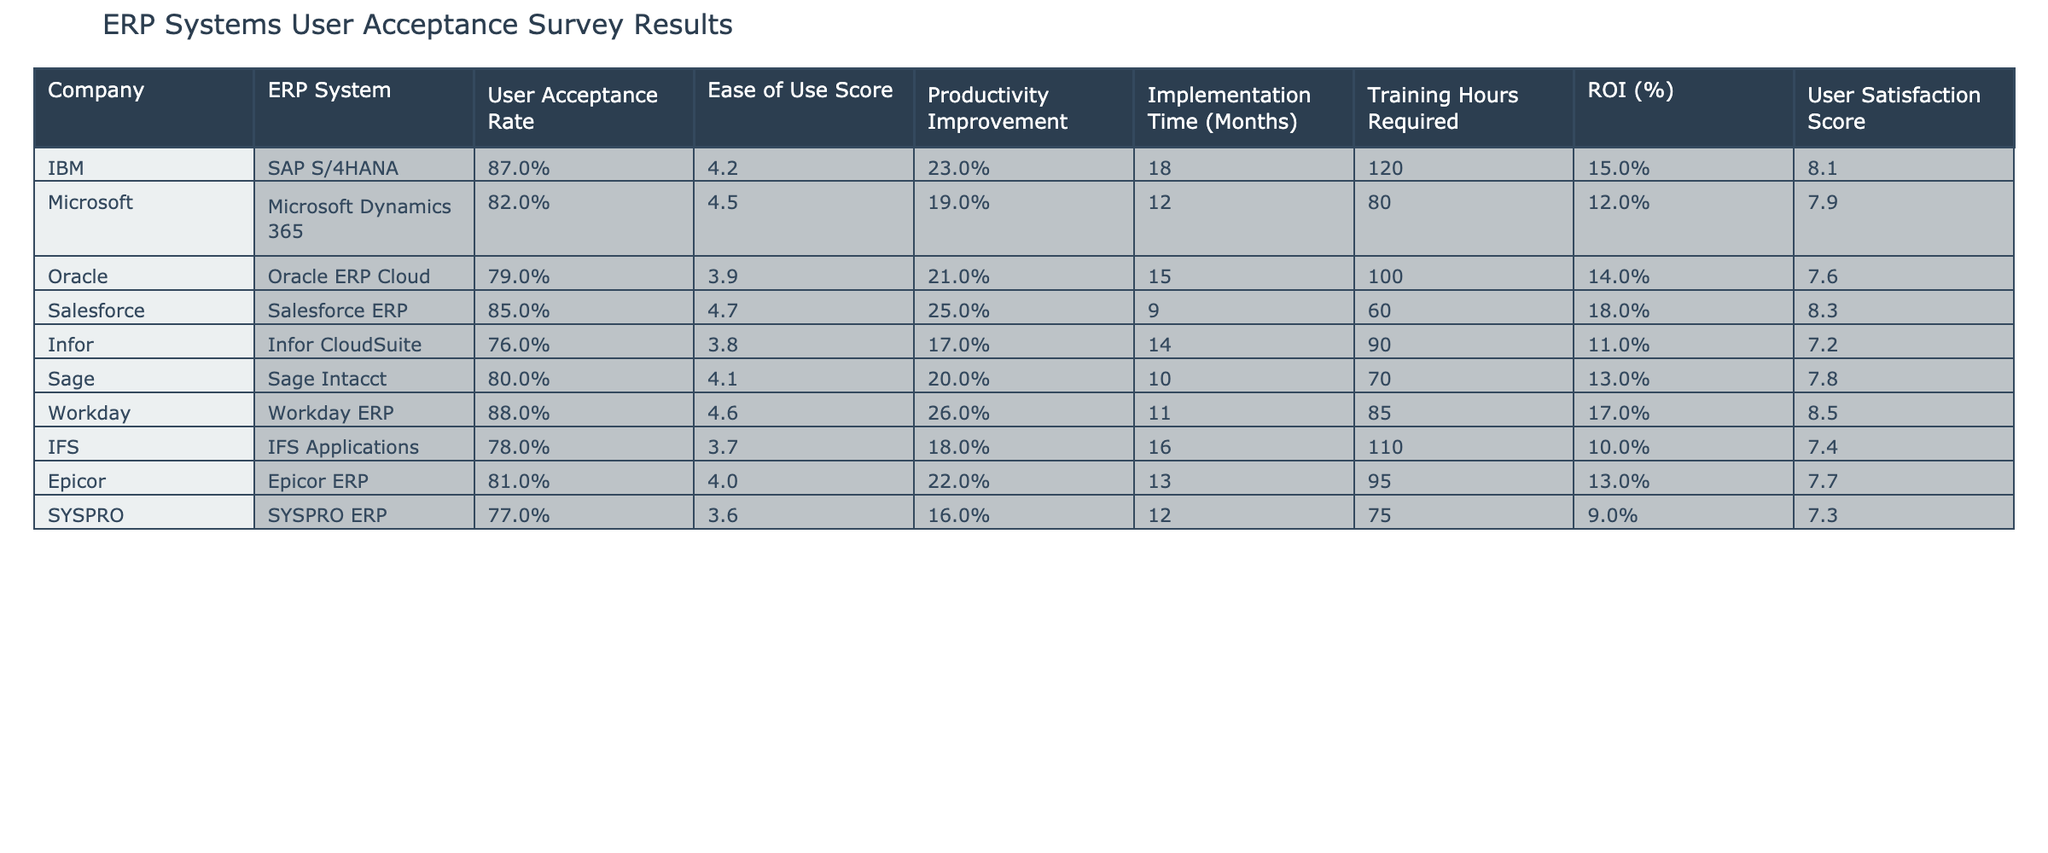What is the highest user acceptance rate among the ERP systems? The user acceptance rates for the systems are: IBM (87%), Microsoft (82%), Oracle (79%), Salesforce (85%), Infor (76%), Sage (80%), Workday (88%), IFS (78%), Epicor (81%), and SYSPRO (77%). The highest rate is 88% for Workday ERP.
Answer: 88% Which ERP system requires the least training hours? The training hours required for each system are: IBM (120), Microsoft (80), Oracle (100), Salesforce (60), Infor (90), Sage (70), Workday (85), IFS (110), Epicor (95), and SYSPRO (75). Salesforce requires the least at 60 hours.
Answer: 60 What is the implementation time for Salesforce ERP? According to the table, the implementation time for Salesforce ERP is 9 months.
Answer: 9 months Is the ROI for Oracle ERP Cloud higher than that of Sage Intacct? The ROI for Oracle ERP Cloud is 14%, while for Sage Intacct it is 13%. Since 14% is greater than 13%, the answer is yes.
Answer: Yes Which ERP system has the highest productivity improvement percentage? The productivity improvement percentages for the systems are: IBM (23%), Microsoft (19%), Oracle (21%), Salesforce (25%), Infor (17%), Sage (20%), Workday (26%), IFS (18%), Epicor (22%), and SYSPRO (16%). Workday has the highest at 26%.
Answer: 26% Calculate the average user satisfaction score across all ERP systems. The user satisfaction scores are: IBM (8.1), Microsoft (7.9), Oracle (7.6), Salesforce (8.3), Infor (7.2), Sage (7.8), Workday (8.5), IFS (7.4), Epicor (7.7), and SYSPRO (7.3). Summing these gives 79.8, and dividing by 10 (the number of systems) results in 7.98.
Answer: 7.98 Does any ERP system have a user satisfaction score of 9 or higher? The user satisfaction scores are all below 9, with the highest being 8.5 for Workday ERP. Therefore, there is no ERP system with a score of 9 or higher.
Answer: No Which company implemented their ERP system in more than a year? The implementation times are: IBM (18 months), Microsoft (12 months), Oracle (15 months), Salesforce (9 months), Infor (14 months), Sage (10 months), Workday (11 months), IFS (16 months), Epicor (13 months), and SYSPRO (12 months). IBM, Oracle, Infor, and IFS all implemented their systems in more than 12 months.
Answer: IBM, Oracle, Infor, IFS What is the relationship between user acceptance rate and ease of use score for the ERP systems? By comparing the user acceptance rates and ease of use scores, a positive correlation can be observed: higher ease of use scores typically align with higher acceptance rates (e.g., Workday has the highest acceptance rate and a score of 4.6). This suggests ease of use might positively impact user acceptance.
Answer: Positive correlation Which ERP system exhibits the lowest productivity improvement? The productivity improvement percentages are: IBM (23%), Microsoft (19%), Oracle (21%), Salesforce (25%), Infor (17%), Sage (20%), Workday (26%), IFS (18%), Epicor (22%), and SYSPRO (16%). Infor has the lowest at 17%.
Answer: 17% 